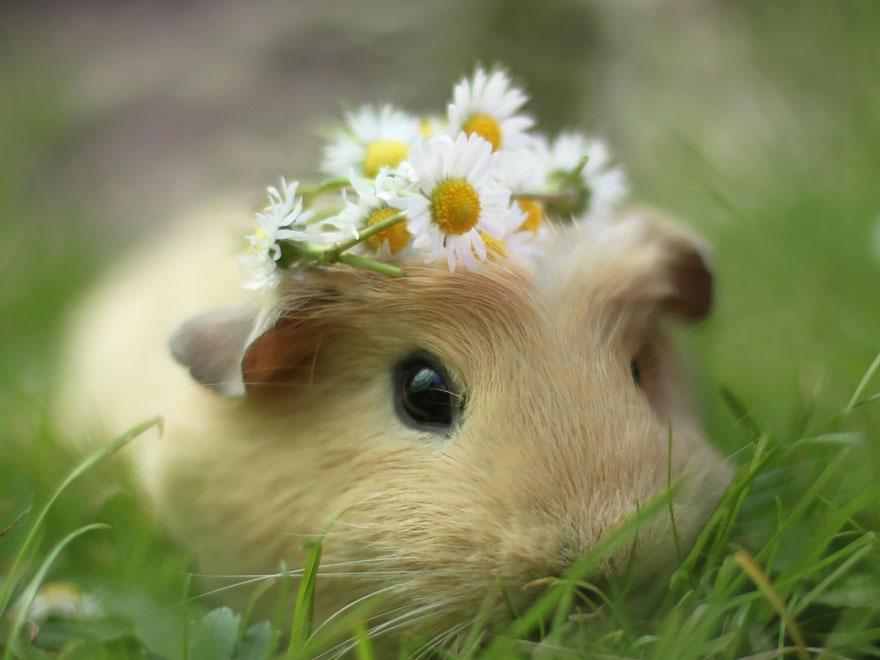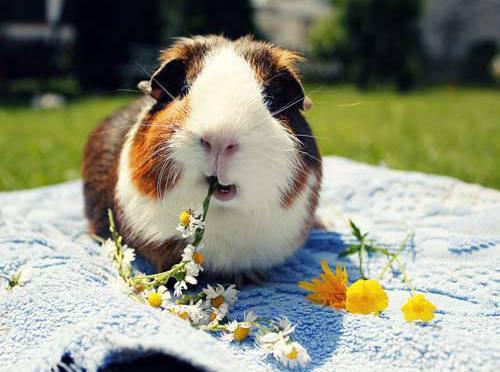The first image is the image on the left, the second image is the image on the right. For the images displayed, is the sentence "One little animal is wearing a bunch of yellow and white daisies on its head." factually correct? Answer yes or no. Yes. 